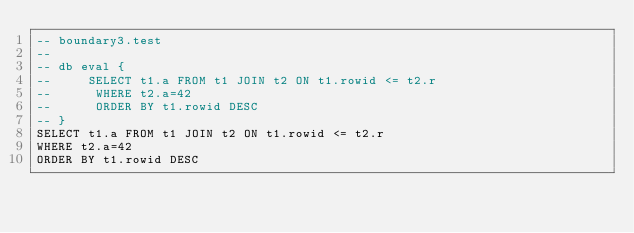Convert code to text. <code><loc_0><loc_0><loc_500><loc_500><_SQL_>-- boundary3.test
-- 
-- db eval {
--     SELECT t1.a FROM t1 JOIN t2 ON t1.rowid <= t2.r
--      WHERE t2.a=42
--      ORDER BY t1.rowid DESC
-- }
SELECT t1.a FROM t1 JOIN t2 ON t1.rowid <= t2.r
WHERE t2.a=42
ORDER BY t1.rowid DESC</code> 